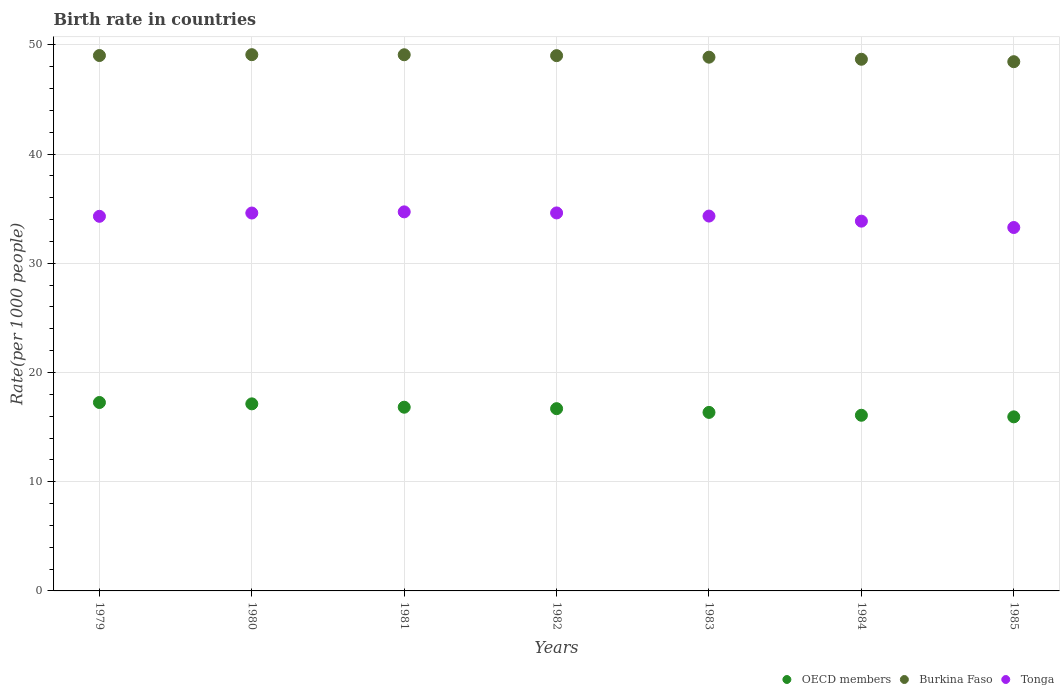How many different coloured dotlines are there?
Make the answer very short. 3. Is the number of dotlines equal to the number of legend labels?
Keep it short and to the point. Yes. What is the birth rate in OECD members in 1980?
Offer a very short reply. 17.13. Across all years, what is the maximum birth rate in Tonga?
Provide a short and direct response. 34.71. Across all years, what is the minimum birth rate in Tonga?
Provide a succinct answer. 33.27. In which year was the birth rate in Burkina Faso minimum?
Your response must be concise. 1985. What is the total birth rate in Tonga in the graph?
Keep it short and to the point. 239.67. What is the difference between the birth rate in Burkina Faso in 1981 and that in 1982?
Your response must be concise. 0.08. What is the difference between the birth rate in Tonga in 1985 and the birth rate in OECD members in 1979?
Provide a succinct answer. 16.02. What is the average birth rate in OECD members per year?
Keep it short and to the point. 16.61. In the year 1980, what is the difference between the birth rate in OECD members and birth rate in Tonga?
Give a very brief answer. -17.47. What is the ratio of the birth rate in OECD members in 1979 to that in 1983?
Keep it short and to the point. 1.06. Is the birth rate in OECD members in 1979 less than that in 1982?
Make the answer very short. No. What is the difference between the highest and the second highest birth rate in Tonga?
Offer a very short reply. 0.1. What is the difference between the highest and the lowest birth rate in Tonga?
Ensure brevity in your answer.  1.43. In how many years, is the birth rate in Tonga greater than the average birth rate in Tonga taken over all years?
Give a very brief answer. 5. Is it the case that in every year, the sum of the birth rate in Burkina Faso and birth rate in Tonga  is greater than the birth rate in OECD members?
Make the answer very short. Yes. Does the birth rate in Burkina Faso monotonically increase over the years?
Provide a succinct answer. No. Are the values on the major ticks of Y-axis written in scientific E-notation?
Give a very brief answer. No. Does the graph contain any zero values?
Offer a terse response. No. Does the graph contain grids?
Provide a succinct answer. Yes. Where does the legend appear in the graph?
Offer a very short reply. Bottom right. How many legend labels are there?
Keep it short and to the point. 3. How are the legend labels stacked?
Make the answer very short. Horizontal. What is the title of the graph?
Your answer should be compact. Birth rate in countries. Does "Greenland" appear as one of the legend labels in the graph?
Provide a succinct answer. No. What is the label or title of the X-axis?
Keep it short and to the point. Years. What is the label or title of the Y-axis?
Give a very brief answer. Rate(per 1000 people). What is the Rate(per 1000 people) in OECD members in 1979?
Offer a terse response. 17.25. What is the Rate(per 1000 people) in Burkina Faso in 1979?
Make the answer very short. 49.02. What is the Rate(per 1000 people) of Tonga in 1979?
Ensure brevity in your answer.  34.3. What is the Rate(per 1000 people) of OECD members in 1980?
Make the answer very short. 17.13. What is the Rate(per 1000 people) of Burkina Faso in 1980?
Your answer should be very brief. 49.1. What is the Rate(per 1000 people) in Tonga in 1980?
Provide a succinct answer. 34.6. What is the Rate(per 1000 people) of OECD members in 1981?
Make the answer very short. 16.82. What is the Rate(per 1000 people) of Burkina Faso in 1981?
Your answer should be compact. 49.09. What is the Rate(per 1000 people) of Tonga in 1981?
Ensure brevity in your answer.  34.71. What is the Rate(per 1000 people) of OECD members in 1982?
Your response must be concise. 16.69. What is the Rate(per 1000 people) of Burkina Faso in 1982?
Provide a succinct answer. 49.01. What is the Rate(per 1000 people) in Tonga in 1982?
Offer a very short reply. 34.61. What is the Rate(per 1000 people) in OECD members in 1983?
Offer a terse response. 16.35. What is the Rate(per 1000 people) of Burkina Faso in 1983?
Offer a terse response. 48.87. What is the Rate(per 1000 people) in Tonga in 1983?
Offer a very short reply. 34.32. What is the Rate(per 1000 people) of OECD members in 1984?
Your answer should be compact. 16.08. What is the Rate(per 1000 people) in Burkina Faso in 1984?
Provide a short and direct response. 48.68. What is the Rate(per 1000 people) of Tonga in 1984?
Provide a short and direct response. 33.86. What is the Rate(per 1000 people) in OECD members in 1985?
Offer a terse response. 15.94. What is the Rate(per 1000 people) of Burkina Faso in 1985?
Provide a short and direct response. 48.46. What is the Rate(per 1000 people) of Tonga in 1985?
Offer a terse response. 33.27. Across all years, what is the maximum Rate(per 1000 people) in OECD members?
Ensure brevity in your answer.  17.25. Across all years, what is the maximum Rate(per 1000 people) in Burkina Faso?
Keep it short and to the point. 49.1. Across all years, what is the maximum Rate(per 1000 people) in Tonga?
Give a very brief answer. 34.71. Across all years, what is the minimum Rate(per 1000 people) in OECD members?
Offer a terse response. 15.94. Across all years, what is the minimum Rate(per 1000 people) of Burkina Faso?
Provide a short and direct response. 48.46. Across all years, what is the minimum Rate(per 1000 people) of Tonga?
Ensure brevity in your answer.  33.27. What is the total Rate(per 1000 people) in OECD members in the graph?
Your answer should be compact. 116.26. What is the total Rate(per 1000 people) in Burkina Faso in the graph?
Offer a very short reply. 342.23. What is the total Rate(per 1000 people) of Tonga in the graph?
Offer a terse response. 239.67. What is the difference between the Rate(per 1000 people) in OECD members in 1979 and that in 1980?
Provide a succinct answer. 0.13. What is the difference between the Rate(per 1000 people) of Burkina Faso in 1979 and that in 1980?
Make the answer very short. -0.08. What is the difference between the Rate(per 1000 people) in Tonga in 1979 and that in 1980?
Your answer should be very brief. -0.3. What is the difference between the Rate(per 1000 people) of OECD members in 1979 and that in 1981?
Offer a very short reply. 0.43. What is the difference between the Rate(per 1000 people) in Burkina Faso in 1979 and that in 1981?
Ensure brevity in your answer.  -0.07. What is the difference between the Rate(per 1000 people) of Tonga in 1979 and that in 1981?
Your answer should be compact. -0.41. What is the difference between the Rate(per 1000 people) in OECD members in 1979 and that in 1982?
Your response must be concise. 0.57. What is the difference between the Rate(per 1000 people) in Burkina Faso in 1979 and that in 1982?
Provide a succinct answer. 0.01. What is the difference between the Rate(per 1000 people) in Tonga in 1979 and that in 1982?
Give a very brief answer. -0.31. What is the difference between the Rate(per 1000 people) of OECD members in 1979 and that in 1983?
Offer a terse response. 0.91. What is the difference between the Rate(per 1000 people) in Burkina Faso in 1979 and that in 1983?
Your response must be concise. 0.15. What is the difference between the Rate(per 1000 people) of Tonga in 1979 and that in 1983?
Your answer should be compact. -0.02. What is the difference between the Rate(per 1000 people) in OECD members in 1979 and that in 1984?
Make the answer very short. 1.17. What is the difference between the Rate(per 1000 people) in Burkina Faso in 1979 and that in 1984?
Your answer should be very brief. 0.34. What is the difference between the Rate(per 1000 people) of Tonga in 1979 and that in 1984?
Ensure brevity in your answer.  0.44. What is the difference between the Rate(per 1000 people) of OECD members in 1979 and that in 1985?
Give a very brief answer. 1.31. What is the difference between the Rate(per 1000 people) of Burkina Faso in 1979 and that in 1985?
Offer a terse response. 0.56. What is the difference between the Rate(per 1000 people) in Tonga in 1979 and that in 1985?
Give a very brief answer. 1.02. What is the difference between the Rate(per 1000 people) of OECD members in 1980 and that in 1981?
Provide a succinct answer. 0.31. What is the difference between the Rate(per 1000 people) of Burkina Faso in 1980 and that in 1981?
Your response must be concise. 0.01. What is the difference between the Rate(per 1000 people) of Tonga in 1980 and that in 1981?
Provide a succinct answer. -0.11. What is the difference between the Rate(per 1000 people) of OECD members in 1980 and that in 1982?
Ensure brevity in your answer.  0.44. What is the difference between the Rate(per 1000 people) in Burkina Faso in 1980 and that in 1982?
Keep it short and to the point. 0.09. What is the difference between the Rate(per 1000 people) of Tonga in 1980 and that in 1982?
Provide a short and direct response. -0.01. What is the difference between the Rate(per 1000 people) of OECD members in 1980 and that in 1983?
Give a very brief answer. 0.78. What is the difference between the Rate(per 1000 people) of Burkina Faso in 1980 and that in 1983?
Offer a terse response. 0.23. What is the difference between the Rate(per 1000 people) of Tonga in 1980 and that in 1983?
Provide a short and direct response. 0.28. What is the difference between the Rate(per 1000 people) of OECD members in 1980 and that in 1984?
Keep it short and to the point. 1.04. What is the difference between the Rate(per 1000 people) of Burkina Faso in 1980 and that in 1984?
Your response must be concise. 0.42. What is the difference between the Rate(per 1000 people) of Tonga in 1980 and that in 1984?
Your response must be concise. 0.74. What is the difference between the Rate(per 1000 people) in OECD members in 1980 and that in 1985?
Give a very brief answer. 1.19. What is the difference between the Rate(per 1000 people) of Burkina Faso in 1980 and that in 1985?
Your answer should be very brief. 0.64. What is the difference between the Rate(per 1000 people) of Tonga in 1980 and that in 1985?
Offer a very short reply. 1.33. What is the difference between the Rate(per 1000 people) of OECD members in 1981 and that in 1982?
Offer a terse response. 0.13. What is the difference between the Rate(per 1000 people) of Burkina Faso in 1981 and that in 1982?
Provide a short and direct response. 0.08. What is the difference between the Rate(per 1000 people) of Tonga in 1981 and that in 1982?
Offer a very short reply. 0.1. What is the difference between the Rate(per 1000 people) of OECD members in 1981 and that in 1983?
Your answer should be very brief. 0.48. What is the difference between the Rate(per 1000 people) of Burkina Faso in 1981 and that in 1983?
Ensure brevity in your answer.  0.22. What is the difference between the Rate(per 1000 people) of Tonga in 1981 and that in 1983?
Offer a very short reply. 0.39. What is the difference between the Rate(per 1000 people) of OECD members in 1981 and that in 1984?
Offer a very short reply. 0.74. What is the difference between the Rate(per 1000 people) in Burkina Faso in 1981 and that in 1984?
Offer a terse response. 0.41. What is the difference between the Rate(per 1000 people) in OECD members in 1981 and that in 1985?
Your response must be concise. 0.88. What is the difference between the Rate(per 1000 people) in Burkina Faso in 1981 and that in 1985?
Ensure brevity in your answer.  0.64. What is the difference between the Rate(per 1000 people) of Tonga in 1981 and that in 1985?
Your answer should be very brief. 1.43. What is the difference between the Rate(per 1000 people) of OECD members in 1982 and that in 1983?
Provide a short and direct response. 0.34. What is the difference between the Rate(per 1000 people) of Burkina Faso in 1982 and that in 1983?
Ensure brevity in your answer.  0.14. What is the difference between the Rate(per 1000 people) in Tonga in 1982 and that in 1983?
Your response must be concise. 0.29. What is the difference between the Rate(per 1000 people) of OECD members in 1982 and that in 1984?
Give a very brief answer. 0.6. What is the difference between the Rate(per 1000 people) of Burkina Faso in 1982 and that in 1984?
Your answer should be very brief. 0.33. What is the difference between the Rate(per 1000 people) of Tonga in 1982 and that in 1984?
Your answer should be compact. 0.75. What is the difference between the Rate(per 1000 people) of OECD members in 1982 and that in 1985?
Your response must be concise. 0.75. What is the difference between the Rate(per 1000 people) of Burkina Faso in 1982 and that in 1985?
Your answer should be very brief. 0.55. What is the difference between the Rate(per 1000 people) in Tonga in 1982 and that in 1985?
Make the answer very short. 1.33. What is the difference between the Rate(per 1000 people) in OECD members in 1983 and that in 1984?
Keep it short and to the point. 0.26. What is the difference between the Rate(per 1000 people) in Burkina Faso in 1983 and that in 1984?
Provide a succinct answer. 0.19. What is the difference between the Rate(per 1000 people) of Tonga in 1983 and that in 1984?
Ensure brevity in your answer.  0.47. What is the difference between the Rate(per 1000 people) in OECD members in 1983 and that in 1985?
Keep it short and to the point. 0.41. What is the difference between the Rate(per 1000 people) in Burkina Faso in 1983 and that in 1985?
Your response must be concise. 0.41. What is the difference between the Rate(per 1000 people) of Tonga in 1983 and that in 1985?
Your answer should be very brief. 1.05. What is the difference between the Rate(per 1000 people) in OECD members in 1984 and that in 1985?
Ensure brevity in your answer.  0.15. What is the difference between the Rate(per 1000 people) in Burkina Faso in 1984 and that in 1985?
Keep it short and to the point. 0.22. What is the difference between the Rate(per 1000 people) of Tonga in 1984 and that in 1985?
Provide a short and direct response. 0.58. What is the difference between the Rate(per 1000 people) in OECD members in 1979 and the Rate(per 1000 people) in Burkina Faso in 1980?
Keep it short and to the point. -31.85. What is the difference between the Rate(per 1000 people) in OECD members in 1979 and the Rate(per 1000 people) in Tonga in 1980?
Offer a very short reply. -17.35. What is the difference between the Rate(per 1000 people) in Burkina Faso in 1979 and the Rate(per 1000 people) in Tonga in 1980?
Offer a terse response. 14.42. What is the difference between the Rate(per 1000 people) in OECD members in 1979 and the Rate(per 1000 people) in Burkina Faso in 1981?
Ensure brevity in your answer.  -31.84. What is the difference between the Rate(per 1000 people) of OECD members in 1979 and the Rate(per 1000 people) of Tonga in 1981?
Offer a terse response. -17.45. What is the difference between the Rate(per 1000 people) of Burkina Faso in 1979 and the Rate(per 1000 people) of Tonga in 1981?
Your answer should be compact. 14.31. What is the difference between the Rate(per 1000 people) in OECD members in 1979 and the Rate(per 1000 people) in Burkina Faso in 1982?
Your answer should be very brief. -31.76. What is the difference between the Rate(per 1000 people) in OECD members in 1979 and the Rate(per 1000 people) in Tonga in 1982?
Your answer should be very brief. -17.36. What is the difference between the Rate(per 1000 people) of Burkina Faso in 1979 and the Rate(per 1000 people) of Tonga in 1982?
Offer a terse response. 14.41. What is the difference between the Rate(per 1000 people) in OECD members in 1979 and the Rate(per 1000 people) in Burkina Faso in 1983?
Provide a short and direct response. -31.62. What is the difference between the Rate(per 1000 people) in OECD members in 1979 and the Rate(per 1000 people) in Tonga in 1983?
Give a very brief answer. -17.07. What is the difference between the Rate(per 1000 people) in Burkina Faso in 1979 and the Rate(per 1000 people) in Tonga in 1983?
Offer a very short reply. 14.7. What is the difference between the Rate(per 1000 people) of OECD members in 1979 and the Rate(per 1000 people) of Burkina Faso in 1984?
Your answer should be very brief. -31.43. What is the difference between the Rate(per 1000 people) of OECD members in 1979 and the Rate(per 1000 people) of Tonga in 1984?
Keep it short and to the point. -16.6. What is the difference between the Rate(per 1000 people) in Burkina Faso in 1979 and the Rate(per 1000 people) in Tonga in 1984?
Your answer should be compact. 15.16. What is the difference between the Rate(per 1000 people) of OECD members in 1979 and the Rate(per 1000 people) of Burkina Faso in 1985?
Your answer should be very brief. -31.2. What is the difference between the Rate(per 1000 people) in OECD members in 1979 and the Rate(per 1000 people) in Tonga in 1985?
Offer a terse response. -16.02. What is the difference between the Rate(per 1000 people) of Burkina Faso in 1979 and the Rate(per 1000 people) of Tonga in 1985?
Make the answer very short. 15.75. What is the difference between the Rate(per 1000 people) in OECD members in 1980 and the Rate(per 1000 people) in Burkina Faso in 1981?
Your answer should be very brief. -31.96. What is the difference between the Rate(per 1000 people) of OECD members in 1980 and the Rate(per 1000 people) of Tonga in 1981?
Provide a short and direct response. -17.58. What is the difference between the Rate(per 1000 people) in Burkina Faso in 1980 and the Rate(per 1000 people) in Tonga in 1981?
Ensure brevity in your answer.  14.39. What is the difference between the Rate(per 1000 people) in OECD members in 1980 and the Rate(per 1000 people) in Burkina Faso in 1982?
Give a very brief answer. -31.88. What is the difference between the Rate(per 1000 people) in OECD members in 1980 and the Rate(per 1000 people) in Tonga in 1982?
Keep it short and to the point. -17.48. What is the difference between the Rate(per 1000 people) of Burkina Faso in 1980 and the Rate(per 1000 people) of Tonga in 1982?
Make the answer very short. 14.49. What is the difference between the Rate(per 1000 people) of OECD members in 1980 and the Rate(per 1000 people) of Burkina Faso in 1983?
Provide a succinct answer. -31.74. What is the difference between the Rate(per 1000 people) of OECD members in 1980 and the Rate(per 1000 people) of Tonga in 1983?
Provide a succinct answer. -17.19. What is the difference between the Rate(per 1000 people) in Burkina Faso in 1980 and the Rate(per 1000 people) in Tonga in 1983?
Keep it short and to the point. 14.78. What is the difference between the Rate(per 1000 people) in OECD members in 1980 and the Rate(per 1000 people) in Burkina Faso in 1984?
Your response must be concise. -31.55. What is the difference between the Rate(per 1000 people) in OECD members in 1980 and the Rate(per 1000 people) in Tonga in 1984?
Offer a terse response. -16.73. What is the difference between the Rate(per 1000 people) in Burkina Faso in 1980 and the Rate(per 1000 people) in Tonga in 1984?
Offer a very short reply. 15.24. What is the difference between the Rate(per 1000 people) of OECD members in 1980 and the Rate(per 1000 people) of Burkina Faso in 1985?
Your response must be concise. -31.33. What is the difference between the Rate(per 1000 people) in OECD members in 1980 and the Rate(per 1000 people) in Tonga in 1985?
Provide a short and direct response. -16.15. What is the difference between the Rate(per 1000 people) of Burkina Faso in 1980 and the Rate(per 1000 people) of Tonga in 1985?
Your answer should be compact. 15.82. What is the difference between the Rate(per 1000 people) of OECD members in 1981 and the Rate(per 1000 people) of Burkina Faso in 1982?
Provide a short and direct response. -32.19. What is the difference between the Rate(per 1000 people) in OECD members in 1981 and the Rate(per 1000 people) in Tonga in 1982?
Give a very brief answer. -17.79. What is the difference between the Rate(per 1000 people) in Burkina Faso in 1981 and the Rate(per 1000 people) in Tonga in 1982?
Make the answer very short. 14.48. What is the difference between the Rate(per 1000 people) of OECD members in 1981 and the Rate(per 1000 people) of Burkina Faso in 1983?
Your answer should be very brief. -32.05. What is the difference between the Rate(per 1000 people) of OECD members in 1981 and the Rate(per 1000 people) of Tonga in 1983?
Provide a short and direct response. -17.5. What is the difference between the Rate(per 1000 people) in Burkina Faso in 1981 and the Rate(per 1000 people) in Tonga in 1983?
Keep it short and to the point. 14.77. What is the difference between the Rate(per 1000 people) in OECD members in 1981 and the Rate(per 1000 people) in Burkina Faso in 1984?
Offer a terse response. -31.86. What is the difference between the Rate(per 1000 people) of OECD members in 1981 and the Rate(per 1000 people) of Tonga in 1984?
Make the answer very short. -17.04. What is the difference between the Rate(per 1000 people) of Burkina Faso in 1981 and the Rate(per 1000 people) of Tonga in 1984?
Ensure brevity in your answer.  15.23. What is the difference between the Rate(per 1000 people) of OECD members in 1981 and the Rate(per 1000 people) of Burkina Faso in 1985?
Make the answer very short. -31.64. What is the difference between the Rate(per 1000 people) of OECD members in 1981 and the Rate(per 1000 people) of Tonga in 1985?
Ensure brevity in your answer.  -16.45. What is the difference between the Rate(per 1000 people) of Burkina Faso in 1981 and the Rate(per 1000 people) of Tonga in 1985?
Offer a terse response. 15.82. What is the difference between the Rate(per 1000 people) of OECD members in 1982 and the Rate(per 1000 people) of Burkina Faso in 1983?
Ensure brevity in your answer.  -32.18. What is the difference between the Rate(per 1000 people) of OECD members in 1982 and the Rate(per 1000 people) of Tonga in 1983?
Offer a very short reply. -17.63. What is the difference between the Rate(per 1000 people) of Burkina Faso in 1982 and the Rate(per 1000 people) of Tonga in 1983?
Provide a succinct answer. 14.69. What is the difference between the Rate(per 1000 people) of OECD members in 1982 and the Rate(per 1000 people) of Burkina Faso in 1984?
Your answer should be compact. -31.99. What is the difference between the Rate(per 1000 people) in OECD members in 1982 and the Rate(per 1000 people) in Tonga in 1984?
Ensure brevity in your answer.  -17.17. What is the difference between the Rate(per 1000 people) in Burkina Faso in 1982 and the Rate(per 1000 people) in Tonga in 1984?
Provide a succinct answer. 15.15. What is the difference between the Rate(per 1000 people) of OECD members in 1982 and the Rate(per 1000 people) of Burkina Faso in 1985?
Ensure brevity in your answer.  -31.77. What is the difference between the Rate(per 1000 people) of OECD members in 1982 and the Rate(per 1000 people) of Tonga in 1985?
Make the answer very short. -16.59. What is the difference between the Rate(per 1000 people) in Burkina Faso in 1982 and the Rate(per 1000 people) in Tonga in 1985?
Your answer should be compact. 15.74. What is the difference between the Rate(per 1000 people) in OECD members in 1983 and the Rate(per 1000 people) in Burkina Faso in 1984?
Provide a succinct answer. -32.33. What is the difference between the Rate(per 1000 people) in OECD members in 1983 and the Rate(per 1000 people) in Tonga in 1984?
Offer a terse response. -17.51. What is the difference between the Rate(per 1000 people) in Burkina Faso in 1983 and the Rate(per 1000 people) in Tonga in 1984?
Provide a succinct answer. 15.01. What is the difference between the Rate(per 1000 people) in OECD members in 1983 and the Rate(per 1000 people) in Burkina Faso in 1985?
Ensure brevity in your answer.  -32.11. What is the difference between the Rate(per 1000 people) in OECD members in 1983 and the Rate(per 1000 people) in Tonga in 1985?
Keep it short and to the point. -16.93. What is the difference between the Rate(per 1000 people) of Burkina Faso in 1983 and the Rate(per 1000 people) of Tonga in 1985?
Give a very brief answer. 15.6. What is the difference between the Rate(per 1000 people) in OECD members in 1984 and the Rate(per 1000 people) in Burkina Faso in 1985?
Ensure brevity in your answer.  -32.37. What is the difference between the Rate(per 1000 people) of OECD members in 1984 and the Rate(per 1000 people) of Tonga in 1985?
Your answer should be very brief. -17.19. What is the difference between the Rate(per 1000 people) in Burkina Faso in 1984 and the Rate(per 1000 people) in Tonga in 1985?
Keep it short and to the point. 15.4. What is the average Rate(per 1000 people) of OECD members per year?
Your answer should be very brief. 16.61. What is the average Rate(per 1000 people) of Burkina Faso per year?
Provide a short and direct response. 48.89. What is the average Rate(per 1000 people) in Tonga per year?
Give a very brief answer. 34.24. In the year 1979, what is the difference between the Rate(per 1000 people) of OECD members and Rate(per 1000 people) of Burkina Faso?
Ensure brevity in your answer.  -31.77. In the year 1979, what is the difference between the Rate(per 1000 people) of OECD members and Rate(per 1000 people) of Tonga?
Keep it short and to the point. -17.05. In the year 1979, what is the difference between the Rate(per 1000 people) in Burkina Faso and Rate(per 1000 people) in Tonga?
Ensure brevity in your answer.  14.72. In the year 1980, what is the difference between the Rate(per 1000 people) in OECD members and Rate(per 1000 people) in Burkina Faso?
Ensure brevity in your answer.  -31.97. In the year 1980, what is the difference between the Rate(per 1000 people) of OECD members and Rate(per 1000 people) of Tonga?
Your answer should be compact. -17.47. In the year 1980, what is the difference between the Rate(per 1000 people) in Burkina Faso and Rate(per 1000 people) in Tonga?
Provide a short and direct response. 14.5. In the year 1981, what is the difference between the Rate(per 1000 people) in OECD members and Rate(per 1000 people) in Burkina Faso?
Offer a terse response. -32.27. In the year 1981, what is the difference between the Rate(per 1000 people) of OECD members and Rate(per 1000 people) of Tonga?
Your answer should be very brief. -17.89. In the year 1981, what is the difference between the Rate(per 1000 people) of Burkina Faso and Rate(per 1000 people) of Tonga?
Ensure brevity in your answer.  14.38. In the year 1982, what is the difference between the Rate(per 1000 people) of OECD members and Rate(per 1000 people) of Burkina Faso?
Offer a very short reply. -32.32. In the year 1982, what is the difference between the Rate(per 1000 people) in OECD members and Rate(per 1000 people) in Tonga?
Provide a succinct answer. -17.92. In the year 1982, what is the difference between the Rate(per 1000 people) of Burkina Faso and Rate(per 1000 people) of Tonga?
Make the answer very short. 14.4. In the year 1983, what is the difference between the Rate(per 1000 people) in OECD members and Rate(per 1000 people) in Burkina Faso?
Ensure brevity in your answer.  -32.53. In the year 1983, what is the difference between the Rate(per 1000 people) in OECD members and Rate(per 1000 people) in Tonga?
Make the answer very short. -17.98. In the year 1983, what is the difference between the Rate(per 1000 people) in Burkina Faso and Rate(per 1000 people) in Tonga?
Provide a succinct answer. 14.55. In the year 1984, what is the difference between the Rate(per 1000 people) in OECD members and Rate(per 1000 people) in Burkina Faso?
Offer a very short reply. -32.6. In the year 1984, what is the difference between the Rate(per 1000 people) of OECD members and Rate(per 1000 people) of Tonga?
Ensure brevity in your answer.  -17.77. In the year 1984, what is the difference between the Rate(per 1000 people) of Burkina Faso and Rate(per 1000 people) of Tonga?
Keep it short and to the point. 14.82. In the year 1985, what is the difference between the Rate(per 1000 people) of OECD members and Rate(per 1000 people) of Burkina Faso?
Give a very brief answer. -32.52. In the year 1985, what is the difference between the Rate(per 1000 people) of OECD members and Rate(per 1000 people) of Tonga?
Your answer should be compact. -17.34. In the year 1985, what is the difference between the Rate(per 1000 people) of Burkina Faso and Rate(per 1000 people) of Tonga?
Offer a very short reply. 15.18. What is the ratio of the Rate(per 1000 people) in OECD members in 1979 to that in 1980?
Offer a terse response. 1.01. What is the ratio of the Rate(per 1000 people) of Burkina Faso in 1979 to that in 1980?
Your answer should be very brief. 1. What is the ratio of the Rate(per 1000 people) in OECD members in 1979 to that in 1981?
Your response must be concise. 1.03. What is the ratio of the Rate(per 1000 people) in Tonga in 1979 to that in 1981?
Provide a succinct answer. 0.99. What is the ratio of the Rate(per 1000 people) in OECD members in 1979 to that in 1982?
Make the answer very short. 1.03. What is the ratio of the Rate(per 1000 people) of Tonga in 1979 to that in 1982?
Your answer should be very brief. 0.99. What is the ratio of the Rate(per 1000 people) in OECD members in 1979 to that in 1983?
Your answer should be compact. 1.06. What is the ratio of the Rate(per 1000 people) in Tonga in 1979 to that in 1983?
Provide a short and direct response. 1. What is the ratio of the Rate(per 1000 people) of OECD members in 1979 to that in 1984?
Offer a very short reply. 1.07. What is the ratio of the Rate(per 1000 people) in Tonga in 1979 to that in 1984?
Offer a terse response. 1.01. What is the ratio of the Rate(per 1000 people) in OECD members in 1979 to that in 1985?
Ensure brevity in your answer.  1.08. What is the ratio of the Rate(per 1000 people) in Burkina Faso in 1979 to that in 1985?
Your answer should be compact. 1.01. What is the ratio of the Rate(per 1000 people) in Tonga in 1979 to that in 1985?
Your answer should be compact. 1.03. What is the ratio of the Rate(per 1000 people) of OECD members in 1980 to that in 1981?
Offer a very short reply. 1.02. What is the ratio of the Rate(per 1000 people) in Burkina Faso in 1980 to that in 1981?
Give a very brief answer. 1. What is the ratio of the Rate(per 1000 people) in OECD members in 1980 to that in 1982?
Offer a terse response. 1.03. What is the ratio of the Rate(per 1000 people) in OECD members in 1980 to that in 1983?
Provide a short and direct response. 1.05. What is the ratio of the Rate(per 1000 people) in Burkina Faso in 1980 to that in 1983?
Give a very brief answer. 1. What is the ratio of the Rate(per 1000 people) in Tonga in 1980 to that in 1983?
Provide a succinct answer. 1.01. What is the ratio of the Rate(per 1000 people) in OECD members in 1980 to that in 1984?
Keep it short and to the point. 1.06. What is the ratio of the Rate(per 1000 people) of Burkina Faso in 1980 to that in 1984?
Ensure brevity in your answer.  1.01. What is the ratio of the Rate(per 1000 people) of OECD members in 1980 to that in 1985?
Offer a terse response. 1.07. What is the ratio of the Rate(per 1000 people) of Burkina Faso in 1980 to that in 1985?
Keep it short and to the point. 1.01. What is the ratio of the Rate(per 1000 people) of Tonga in 1980 to that in 1985?
Provide a succinct answer. 1.04. What is the ratio of the Rate(per 1000 people) of Burkina Faso in 1981 to that in 1982?
Provide a succinct answer. 1. What is the ratio of the Rate(per 1000 people) of Tonga in 1981 to that in 1982?
Offer a terse response. 1. What is the ratio of the Rate(per 1000 people) in OECD members in 1981 to that in 1983?
Offer a terse response. 1.03. What is the ratio of the Rate(per 1000 people) in Tonga in 1981 to that in 1983?
Your response must be concise. 1.01. What is the ratio of the Rate(per 1000 people) in OECD members in 1981 to that in 1984?
Your answer should be compact. 1.05. What is the ratio of the Rate(per 1000 people) of Burkina Faso in 1981 to that in 1984?
Offer a terse response. 1.01. What is the ratio of the Rate(per 1000 people) in Tonga in 1981 to that in 1984?
Offer a terse response. 1.03. What is the ratio of the Rate(per 1000 people) of OECD members in 1981 to that in 1985?
Your answer should be compact. 1.06. What is the ratio of the Rate(per 1000 people) of Burkina Faso in 1981 to that in 1985?
Your response must be concise. 1.01. What is the ratio of the Rate(per 1000 people) of Tonga in 1981 to that in 1985?
Give a very brief answer. 1.04. What is the ratio of the Rate(per 1000 people) in OECD members in 1982 to that in 1983?
Your response must be concise. 1.02. What is the ratio of the Rate(per 1000 people) of Tonga in 1982 to that in 1983?
Give a very brief answer. 1.01. What is the ratio of the Rate(per 1000 people) of OECD members in 1982 to that in 1984?
Ensure brevity in your answer.  1.04. What is the ratio of the Rate(per 1000 people) in Burkina Faso in 1982 to that in 1984?
Give a very brief answer. 1.01. What is the ratio of the Rate(per 1000 people) in Tonga in 1982 to that in 1984?
Make the answer very short. 1.02. What is the ratio of the Rate(per 1000 people) of OECD members in 1982 to that in 1985?
Provide a succinct answer. 1.05. What is the ratio of the Rate(per 1000 people) in Burkina Faso in 1982 to that in 1985?
Keep it short and to the point. 1.01. What is the ratio of the Rate(per 1000 people) of Tonga in 1982 to that in 1985?
Give a very brief answer. 1.04. What is the ratio of the Rate(per 1000 people) of OECD members in 1983 to that in 1984?
Give a very brief answer. 1.02. What is the ratio of the Rate(per 1000 people) in Tonga in 1983 to that in 1984?
Your answer should be very brief. 1.01. What is the ratio of the Rate(per 1000 people) of OECD members in 1983 to that in 1985?
Your answer should be very brief. 1.03. What is the ratio of the Rate(per 1000 people) in Burkina Faso in 1983 to that in 1985?
Offer a terse response. 1.01. What is the ratio of the Rate(per 1000 people) of Tonga in 1983 to that in 1985?
Offer a terse response. 1.03. What is the ratio of the Rate(per 1000 people) in OECD members in 1984 to that in 1985?
Offer a terse response. 1.01. What is the ratio of the Rate(per 1000 people) of Burkina Faso in 1984 to that in 1985?
Offer a terse response. 1. What is the ratio of the Rate(per 1000 people) in Tonga in 1984 to that in 1985?
Offer a very short reply. 1.02. What is the difference between the highest and the second highest Rate(per 1000 people) of OECD members?
Your response must be concise. 0.13. What is the difference between the highest and the second highest Rate(per 1000 people) of Burkina Faso?
Your response must be concise. 0.01. What is the difference between the highest and the second highest Rate(per 1000 people) in Tonga?
Make the answer very short. 0.1. What is the difference between the highest and the lowest Rate(per 1000 people) of OECD members?
Your answer should be very brief. 1.31. What is the difference between the highest and the lowest Rate(per 1000 people) of Burkina Faso?
Offer a very short reply. 0.64. What is the difference between the highest and the lowest Rate(per 1000 people) of Tonga?
Your answer should be very brief. 1.43. 